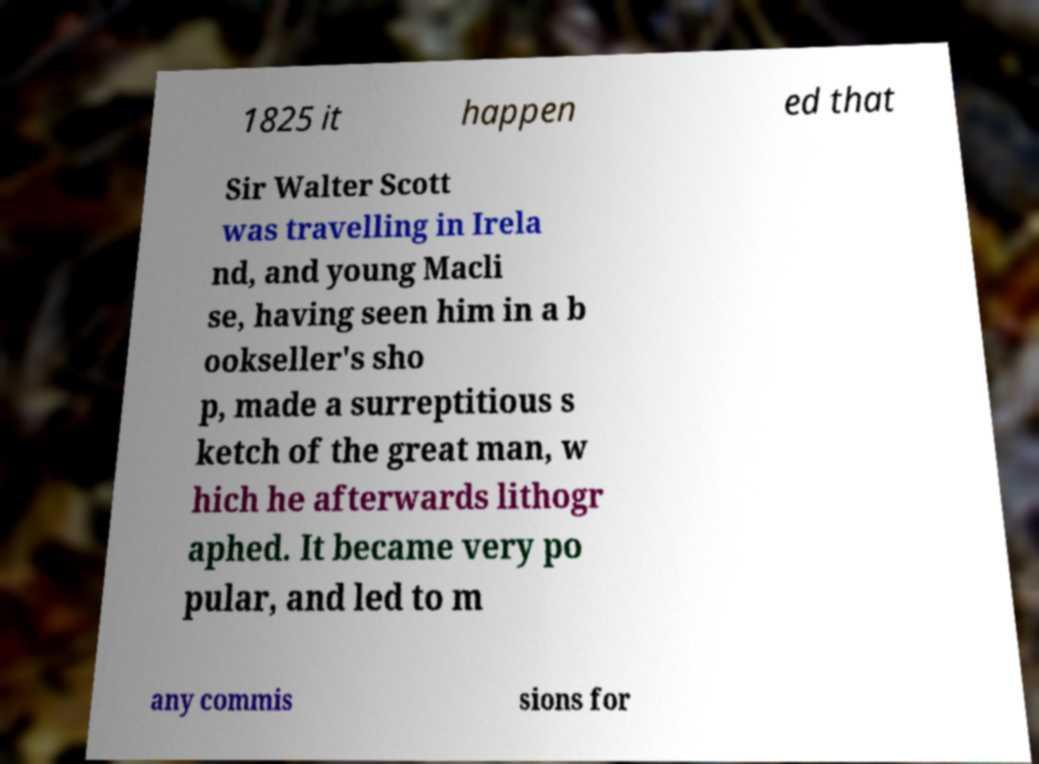Could you assist in decoding the text presented in this image and type it out clearly? 1825 it happen ed that Sir Walter Scott was travelling in Irela nd, and young Macli se, having seen him in a b ookseller's sho p, made a surreptitious s ketch of the great man, w hich he afterwards lithogr aphed. It became very po pular, and led to m any commis sions for 